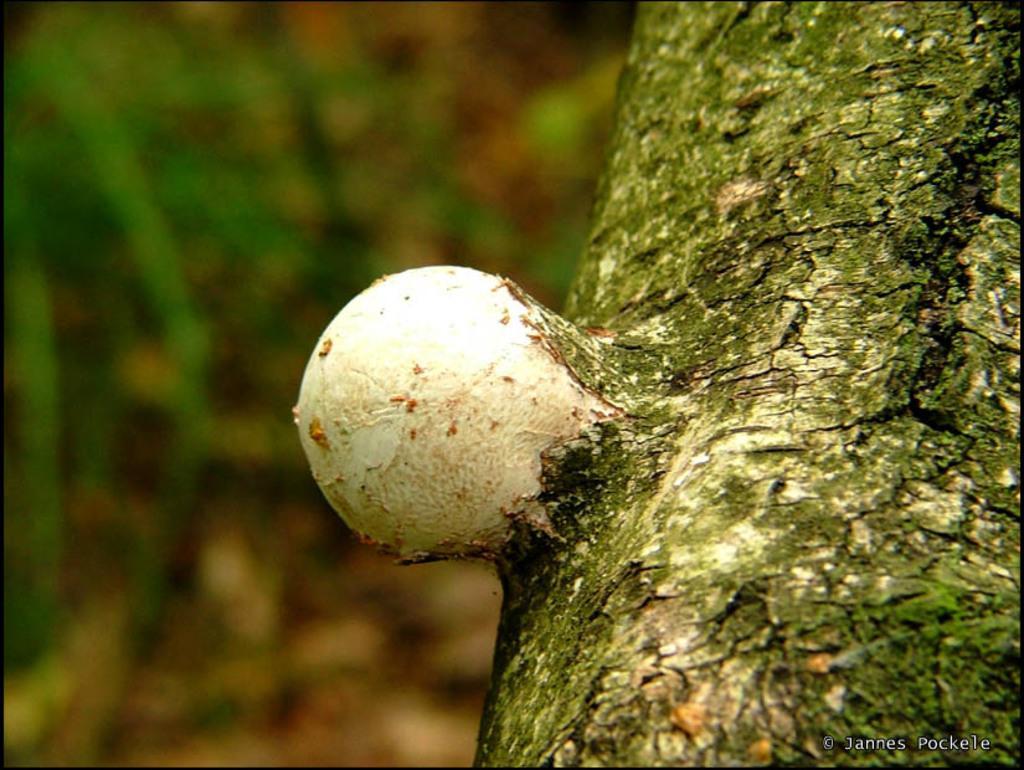Can you describe this image briefly? In this image on the right side there is a trunk of tree, there is an object, on the left the image is blur. 